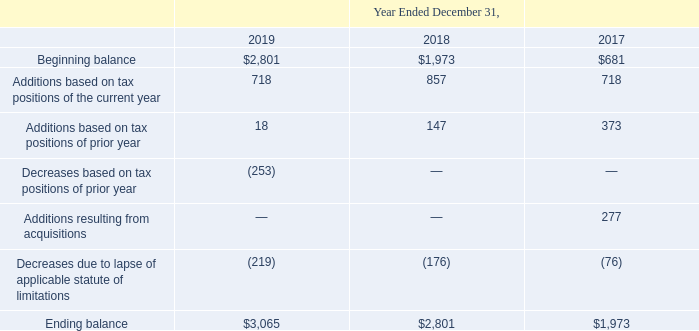A reconciliation of the beginning and ending amounts of unrecognized tax benefits (without related interest expense) is as follows (in thousands):
Our effective income tax rates were 9.5%, (84.0)% and 9.3% for the years ended December 31, 2019, 2018 and 2017, respectively. Our effective tax rates were below the statutory rate primarily due to the tax windfall benefits from employee stockbased payment transactions, foreign derived intangible income deductions and research and development tax credits claimed, partially offset by the impact of non-deductible meal and entertainment expenses and state taxes.
We recognize a valuation allowance if, based on the weight of available evidence, both positive and negative, it is more likely than not that some portion, or all, of net deferred tax assets will not be realized. Due to the uncertainty of realization of  and development tax credits totaling $0.3 million, we established a valuation allowance of $0.3 million during the second quarter of 2019, which remained at $0.3 million as of December 31, 2019. As of December 31, 2018, based on our historical and expected future taxable earnings, we believed it was more likely than not that we would realize all of the benefit of the existing deferred tax assets. Accordingly, we did not record a valuation allowance as of December 31, 2018.
We apply guidance for uncertainty in income taxes that requires the application of a more likely than not threshold to the recognition and de-recognition of uncertain tax positions. If the recognition threshold is met, this guidance permits us to recognize a tax benefit measured at the largest amount of the tax benefit that, in our judgment, is more likely than not to be realized upon settlement. We recorded unrecognized tax benefits of $0.6 million, $0.8 million and $1.0 million for research and development tax credits claimed during the years ended December 31, 2019, 2018 and 2017, respectively.
As of December 31, 2019 and 2018, we accrued $0.2 million and $0.1 million of total interest related to unrecognized tax benefits, respectively. We recognize interest and penalties related to unrecognized tax benefits as a component of income tax expense.
We are not aware of any events that make it reasonably possible that there would be a significant change in our unrecognized tax benefits over the next twelve months. Our cumulative liability for uncertain tax positions was $3.1 million and $2.8 million as of December 31, 2019 and 2018, respectively, and if recognized, would reduce our income tax expense and the effective tax rate.
We file income tax returns in the United States and Canada. We are no longer subject to U.S. income tax examinations for years prior to 2016, with the exception that operating loss carryforwards generated prior to 2016 may be subject to tax audit adjustment. We are generally no longer subject to state and local income tax examinations by tax authorities for years prior to 2016.
As of December 31, 2019, we had federal net operating loss carryforwards of $4.9 million, which are scheduled to begin to expire in 2030. As of December 31, 2019, we had state net operating loss carryforwards of $1.7 million, which are scheduled to begin to expire in 2027. As of December 31, 2019, we had federal research and development tax credit carryforwards of $5.2 million, which are scheduled to begin to expire in 2038. As of December 31, 2019, we had state research and development tax credit carryforwards of $4.3 million, which are scheduled to begin to expire in 2021. The federal net operating loss carryforward arose in connection with the 2013 acquisition of EnergyHub. Utilization of net operating loss carryforwards may be subject to annual limitations due to ownership change limitations as provided by the Internal Revenue Code of 1986, as amended.
What was the effective income tax rate in 2019?
Answer scale should be: percent. 9.5. What was the beginning balance in 2019?
Answer scale should be: thousand. 2,801. Which years does the table provide information for the reconciliation of the beginning and ending amounts of unrecognized tax benefits? 2019, 2018, 2017. How many years did the beginning balance exceed $2,000 thousand? 2019
Answer: 1. What was the change in the Additions based on tax positions of prior year between 2017 and 2018?
Answer scale should be: thousand. 147-373
Answer: -226. What was the percentage change in the ending balance between 2018 and 2019?
Answer scale should be: percent. (3,065-2,801)/2,801
Answer: 9.43. 